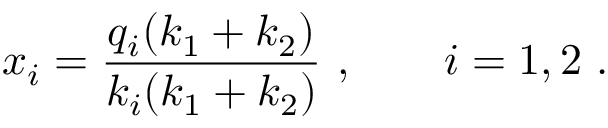Convert formula to latex. <formula><loc_0><loc_0><loc_500><loc_500>x _ { i } = \frac { q _ { i } ( k _ { 1 } + k _ { 2 } ) } { k _ { i } ( k _ { 1 } + k _ { 2 } ) } , \quad i = 1 , 2 .</formula> 